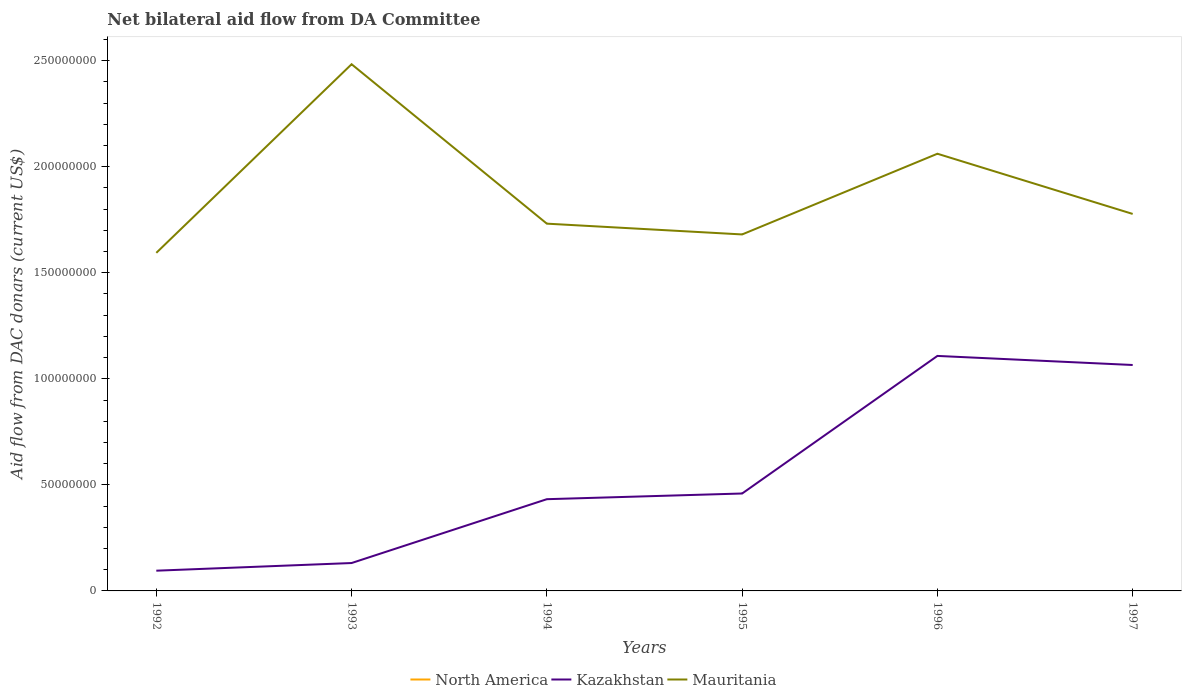How many different coloured lines are there?
Ensure brevity in your answer.  2. Is the number of lines equal to the number of legend labels?
Provide a short and direct response. No. Across all years, what is the maximum aid flow in in Kazakhstan?
Keep it short and to the point. 9.54e+06. What is the total aid flow in in Mauritania in the graph?
Offer a terse response. 7.06e+07. What is the difference between the highest and the second highest aid flow in in Mauritania?
Offer a very short reply. 8.89e+07. How many years are there in the graph?
Offer a terse response. 6. What is the difference between two consecutive major ticks on the Y-axis?
Provide a succinct answer. 5.00e+07. Are the values on the major ticks of Y-axis written in scientific E-notation?
Give a very brief answer. No. Does the graph contain any zero values?
Your answer should be compact. Yes. Where does the legend appear in the graph?
Offer a very short reply. Bottom center. How many legend labels are there?
Provide a succinct answer. 3. How are the legend labels stacked?
Your answer should be compact. Horizontal. What is the title of the graph?
Your answer should be very brief. Net bilateral aid flow from DA Committee. Does "New Zealand" appear as one of the legend labels in the graph?
Your answer should be very brief. No. What is the label or title of the Y-axis?
Give a very brief answer. Aid flow from DAC donars (current US$). What is the Aid flow from DAC donars (current US$) in Kazakhstan in 1992?
Provide a succinct answer. 9.54e+06. What is the Aid flow from DAC donars (current US$) of Mauritania in 1992?
Offer a terse response. 1.59e+08. What is the Aid flow from DAC donars (current US$) of Kazakhstan in 1993?
Your response must be concise. 1.32e+07. What is the Aid flow from DAC donars (current US$) in Mauritania in 1993?
Your response must be concise. 2.48e+08. What is the Aid flow from DAC donars (current US$) of Kazakhstan in 1994?
Your answer should be compact. 4.32e+07. What is the Aid flow from DAC donars (current US$) in Mauritania in 1994?
Ensure brevity in your answer.  1.73e+08. What is the Aid flow from DAC donars (current US$) in Kazakhstan in 1995?
Ensure brevity in your answer.  4.59e+07. What is the Aid flow from DAC donars (current US$) of Mauritania in 1995?
Your answer should be very brief. 1.68e+08. What is the Aid flow from DAC donars (current US$) in Kazakhstan in 1996?
Offer a very short reply. 1.11e+08. What is the Aid flow from DAC donars (current US$) of Mauritania in 1996?
Make the answer very short. 2.06e+08. What is the Aid flow from DAC donars (current US$) of Kazakhstan in 1997?
Offer a terse response. 1.07e+08. What is the Aid flow from DAC donars (current US$) in Mauritania in 1997?
Provide a short and direct response. 1.78e+08. Across all years, what is the maximum Aid flow from DAC donars (current US$) in Kazakhstan?
Provide a succinct answer. 1.11e+08. Across all years, what is the maximum Aid flow from DAC donars (current US$) of Mauritania?
Give a very brief answer. 2.48e+08. Across all years, what is the minimum Aid flow from DAC donars (current US$) in Kazakhstan?
Your answer should be compact. 9.54e+06. Across all years, what is the minimum Aid flow from DAC donars (current US$) of Mauritania?
Make the answer very short. 1.59e+08. What is the total Aid flow from DAC donars (current US$) in North America in the graph?
Your answer should be compact. 0. What is the total Aid flow from DAC donars (current US$) in Kazakhstan in the graph?
Your answer should be very brief. 3.29e+08. What is the total Aid flow from DAC donars (current US$) of Mauritania in the graph?
Your answer should be compact. 1.13e+09. What is the difference between the Aid flow from DAC donars (current US$) in Kazakhstan in 1992 and that in 1993?
Provide a short and direct response. -3.61e+06. What is the difference between the Aid flow from DAC donars (current US$) in Mauritania in 1992 and that in 1993?
Keep it short and to the point. -8.89e+07. What is the difference between the Aid flow from DAC donars (current US$) of Kazakhstan in 1992 and that in 1994?
Ensure brevity in your answer.  -3.37e+07. What is the difference between the Aid flow from DAC donars (current US$) of Mauritania in 1992 and that in 1994?
Ensure brevity in your answer.  -1.38e+07. What is the difference between the Aid flow from DAC donars (current US$) of Kazakhstan in 1992 and that in 1995?
Provide a succinct answer. -3.64e+07. What is the difference between the Aid flow from DAC donars (current US$) of Mauritania in 1992 and that in 1995?
Offer a very short reply. -8.68e+06. What is the difference between the Aid flow from DAC donars (current US$) in Kazakhstan in 1992 and that in 1996?
Provide a short and direct response. -1.01e+08. What is the difference between the Aid flow from DAC donars (current US$) in Mauritania in 1992 and that in 1996?
Your answer should be compact. -4.67e+07. What is the difference between the Aid flow from DAC donars (current US$) in Kazakhstan in 1992 and that in 1997?
Your answer should be very brief. -9.70e+07. What is the difference between the Aid flow from DAC donars (current US$) in Mauritania in 1992 and that in 1997?
Your response must be concise. -1.84e+07. What is the difference between the Aid flow from DAC donars (current US$) in Kazakhstan in 1993 and that in 1994?
Give a very brief answer. -3.01e+07. What is the difference between the Aid flow from DAC donars (current US$) of Mauritania in 1993 and that in 1994?
Give a very brief answer. 7.52e+07. What is the difference between the Aid flow from DAC donars (current US$) in Kazakhstan in 1993 and that in 1995?
Give a very brief answer. -3.28e+07. What is the difference between the Aid flow from DAC donars (current US$) of Mauritania in 1993 and that in 1995?
Your answer should be very brief. 8.02e+07. What is the difference between the Aid flow from DAC donars (current US$) of Kazakhstan in 1993 and that in 1996?
Your answer should be very brief. -9.76e+07. What is the difference between the Aid flow from DAC donars (current US$) in Mauritania in 1993 and that in 1996?
Give a very brief answer. 4.22e+07. What is the difference between the Aid flow from DAC donars (current US$) of Kazakhstan in 1993 and that in 1997?
Offer a terse response. -9.34e+07. What is the difference between the Aid flow from DAC donars (current US$) of Mauritania in 1993 and that in 1997?
Offer a very short reply. 7.06e+07. What is the difference between the Aid flow from DAC donars (current US$) in Kazakhstan in 1994 and that in 1995?
Make the answer very short. -2.68e+06. What is the difference between the Aid flow from DAC donars (current US$) in Mauritania in 1994 and that in 1995?
Keep it short and to the point. 5.08e+06. What is the difference between the Aid flow from DAC donars (current US$) in Kazakhstan in 1994 and that in 1996?
Keep it short and to the point. -6.76e+07. What is the difference between the Aid flow from DAC donars (current US$) in Mauritania in 1994 and that in 1996?
Your answer should be very brief. -3.30e+07. What is the difference between the Aid flow from DAC donars (current US$) in Kazakhstan in 1994 and that in 1997?
Ensure brevity in your answer.  -6.33e+07. What is the difference between the Aid flow from DAC donars (current US$) in Mauritania in 1994 and that in 1997?
Ensure brevity in your answer.  -4.59e+06. What is the difference between the Aid flow from DAC donars (current US$) in Kazakhstan in 1995 and that in 1996?
Your answer should be compact. -6.49e+07. What is the difference between the Aid flow from DAC donars (current US$) of Mauritania in 1995 and that in 1996?
Make the answer very short. -3.80e+07. What is the difference between the Aid flow from DAC donars (current US$) in Kazakhstan in 1995 and that in 1997?
Ensure brevity in your answer.  -6.06e+07. What is the difference between the Aid flow from DAC donars (current US$) in Mauritania in 1995 and that in 1997?
Ensure brevity in your answer.  -9.67e+06. What is the difference between the Aid flow from DAC donars (current US$) of Kazakhstan in 1996 and that in 1997?
Provide a short and direct response. 4.28e+06. What is the difference between the Aid flow from DAC donars (current US$) of Mauritania in 1996 and that in 1997?
Your answer should be very brief. 2.84e+07. What is the difference between the Aid flow from DAC donars (current US$) of Kazakhstan in 1992 and the Aid flow from DAC donars (current US$) of Mauritania in 1993?
Offer a very short reply. -2.39e+08. What is the difference between the Aid flow from DAC donars (current US$) of Kazakhstan in 1992 and the Aid flow from DAC donars (current US$) of Mauritania in 1994?
Make the answer very short. -1.64e+08. What is the difference between the Aid flow from DAC donars (current US$) of Kazakhstan in 1992 and the Aid flow from DAC donars (current US$) of Mauritania in 1995?
Keep it short and to the point. -1.59e+08. What is the difference between the Aid flow from DAC donars (current US$) in Kazakhstan in 1992 and the Aid flow from DAC donars (current US$) in Mauritania in 1996?
Offer a terse response. -1.97e+08. What is the difference between the Aid flow from DAC donars (current US$) in Kazakhstan in 1992 and the Aid flow from DAC donars (current US$) in Mauritania in 1997?
Your response must be concise. -1.68e+08. What is the difference between the Aid flow from DAC donars (current US$) of Kazakhstan in 1993 and the Aid flow from DAC donars (current US$) of Mauritania in 1994?
Make the answer very short. -1.60e+08. What is the difference between the Aid flow from DAC donars (current US$) in Kazakhstan in 1993 and the Aid flow from DAC donars (current US$) in Mauritania in 1995?
Keep it short and to the point. -1.55e+08. What is the difference between the Aid flow from DAC donars (current US$) of Kazakhstan in 1993 and the Aid flow from DAC donars (current US$) of Mauritania in 1996?
Offer a terse response. -1.93e+08. What is the difference between the Aid flow from DAC donars (current US$) in Kazakhstan in 1993 and the Aid flow from DAC donars (current US$) in Mauritania in 1997?
Your answer should be very brief. -1.65e+08. What is the difference between the Aid flow from DAC donars (current US$) in Kazakhstan in 1994 and the Aid flow from DAC donars (current US$) in Mauritania in 1995?
Your response must be concise. -1.25e+08. What is the difference between the Aid flow from DAC donars (current US$) in Kazakhstan in 1994 and the Aid flow from DAC donars (current US$) in Mauritania in 1996?
Your answer should be very brief. -1.63e+08. What is the difference between the Aid flow from DAC donars (current US$) in Kazakhstan in 1994 and the Aid flow from DAC donars (current US$) in Mauritania in 1997?
Provide a succinct answer. -1.34e+08. What is the difference between the Aid flow from DAC donars (current US$) in Kazakhstan in 1995 and the Aid flow from DAC donars (current US$) in Mauritania in 1996?
Provide a short and direct response. -1.60e+08. What is the difference between the Aid flow from DAC donars (current US$) of Kazakhstan in 1995 and the Aid flow from DAC donars (current US$) of Mauritania in 1997?
Your response must be concise. -1.32e+08. What is the difference between the Aid flow from DAC donars (current US$) in Kazakhstan in 1996 and the Aid flow from DAC donars (current US$) in Mauritania in 1997?
Your answer should be compact. -6.70e+07. What is the average Aid flow from DAC donars (current US$) in North America per year?
Ensure brevity in your answer.  0. What is the average Aid flow from DAC donars (current US$) of Kazakhstan per year?
Make the answer very short. 5.49e+07. What is the average Aid flow from DAC donars (current US$) in Mauritania per year?
Your answer should be very brief. 1.89e+08. In the year 1992, what is the difference between the Aid flow from DAC donars (current US$) in Kazakhstan and Aid flow from DAC donars (current US$) in Mauritania?
Offer a very short reply. -1.50e+08. In the year 1993, what is the difference between the Aid flow from DAC donars (current US$) in Kazakhstan and Aid flow from DAC donars (current US$) in Mauritania?
Your answer should be compact. -2.35e+08. In the year 1994, what is the difference between the Aid flow from DAC donars (current US$) in Kazakhstan and Aid flow from DAC donars (current US$) in Mauritania?
Provide a short and direct response. -1.30e+08. In the year 1995, what is the difference between the Aid flow from DAC donars (current US$) of Kazakhstan and Aid flow from DAC donars (current US$) of Mauritania?
Your response must be concise. -1.22e+08. In the year 1996, what is the difference between the Aid flow from DAC donars (current US$) in Kazakhstan and Aid flow from DAC donars (current US$) in Mauritania?
Provide a short and direct response. -9.53e+07. In the year 1997, what is the difference between the Aid flow from DAC donars (current US$) in Kazakhstan and Aid flow from DAC donars (current US$) in Mauritania?
Provide a succinct answer. -7.12e+07. What is the ratio of the Aid flow from DAC donars (current US$) of Kazakhstan in 1992 to that in 1993?
Keep it short and to the point. 0.73. What is the ratio of the Aid flow from DAC donars (current US$) in Mauritania in 1992 to that in 1993?
Give a very brief answer. 0.64. What is the ratio of the Aid flow from DAC donars (current US$) in Kazakhstan in 1992 to that in 1994?
Ensure brevity in your answer.  0.22. What is the ratio of the Aid flow from DAC donars (current US$) in Mauritania in 1992 to that in 1994?
Your answer should be compact. 0.92. What is the ratio of the Aid flow from DAC donars (current US$) of Kazakhstan in 1992 to that in 1995?
Provide a short and direct response. 0.21. What is the ratio of the Aid flow from DAC donars (current US$) in Mauritania in 1992 to that in 1995?
Offer a terse response. 0.95. What is the ratio of the Aid flow from DAC donars (current US$) of Kazakhstan in 1992 to that in 1996?
Keep it short and to the point. 0.09. What is the ratio of the Aid flow from DAC donars (current US$) of Mauritania in 1992 to that in 1996?
Offer a very short reply. 0.77. What is the ratio of the Aid flow from DAC donars (current US$) in Kazakhstan in 1992 to that in 1997?
Give a very brief answer. 0.09. What is the ratio of the Aid flow from DAC donars (current US$) in Mauritania in 1992 to that in 1997?
Your answer should be compact. 0.9. What is the ratio of the Aid flow from DAC donars (current US$) in Kazakhstan in 1993 to that in 1994?
Make the answer very short. 0.3. What is the ratio of the Aid flow from DAC donars (current US$) of Mauritania in 1993 to that in 1994?
Your response must be concise. 1.43. What is the ratio of the Aid flow from DAC donars (current US$) of Kazakhstan in 1993 to that in 1995?
Make the answer very short. 0.29. What is the ratio of the Aid flow from DAC donars (current US$) in Mauritania in 1993 to that in 1995?
Your answer should be compact. 1.48. What is the ratio of the Aid flow from DAC donars (current US$) of Kazakhstan in 1993 to that in 1996?
Offer a terse response. 0.12. What is the ratio of the Aid flow from DAC donars (current US$) of Mauritania in 1993 to that in 1996?
Give a very brief answer. 1.2. What is the ratio of the Aid flow from DAC donars (current US$) in Kazakhstan in 1993 to that in 1997?
Offer a terse response. 0.12. What is the ratio of the Aid flow from DAC donars (current US$) of Mauritania in 1993 to that in 1997?
Your response must be concise. 1.4. What is the ratio of the Aid flow from DAC donars (current US$) in Kazakhstan in 1994 to that in 1995?
Provide a short and direct response. 0.94. What is the ratio of the Aid flow from DAC donars (current US$) of Mauritania in 1994 to that in 1995?
Provide a short and direct response. 1.03. What is the ratio of the Aid flow from DAC donars (current US$) of Kazakhstan in 1994 to that in 1996?
Provide a short and direct response. 0.39. What is the ratio of the Aid flow from DAC donars (current US$) of Mauritania in 1994 to that in 1996?
Your answer should be very brief. 0.84. What is the ratio of the Aid flow from DAC donars (current US$) of Kazakhstan in 1994 to that in 1997?
Offer a very short reply. 0.41. What is the ratio of the Aid flow from DAC donars (current US$) in Mauritania in 1994 to that in 1997?
Give a very brief answer. 0.97. What is the ratio of the Aid flow from DAC donars (current US$) of Kazakhstan in 1995 to that in 1996?
Keep it short and to the point. 0.41. What is the ratio of the Aid flow from DAC donars (current US$) of Mauritania in 1995 to that in 1996?
Keep it short and to the point. 0.82. What is the ratio of the Aid flow from DAC donars (current US$) in Kazakhstan in 1995 to that in 1997?
Give a very brief answer. 0.43. What is the ratio of the Aid flow from DAC donars (current US$) of Mauritania in 1995 to that in 1997?
Offer a very short reply. 0.95. What is the ratio of the Aid flow from DAC donars (current US$) of Kazakhstan in 1996 to that in 1997?
Offer a very short reply. 1.04. What is the ratio of the Aid flow from DAC donars (current US$) in Mauritania in 1996 to that in 1997?
Provide a succinct answer. 1.16. What is the difference between the highest and the second highest Aid flow from DAC donars (current US$) of Kazakhstan?
Your response must be concise. 4.28e+06. What is the difference between the highest and the second highest Aid flow from DAC donars (current US$) in Mauritania?
Keep it short and to the point. 4.22e+07. What is the difference between the highest and the lowest Aid flow from DAC donars (current US$) in Kazakhstan?
Ensure brevity in your answer.  1.01e+08. What is the difference between the highest and the lowest Aid flow from DAC donars (current US$) of Mauritania?
Offer a terse response. 8.89e+07. 